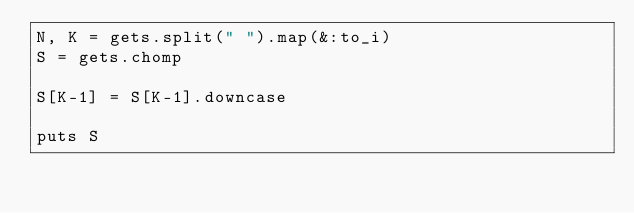<code> <loc_0><loc_0><loc_500><loc_500><_Ruby_>N, K = gets.split(" ").map(&:to_i)
S = gets.chomp

S[K-1] = S[K-1].downcase

puts S
</code> 